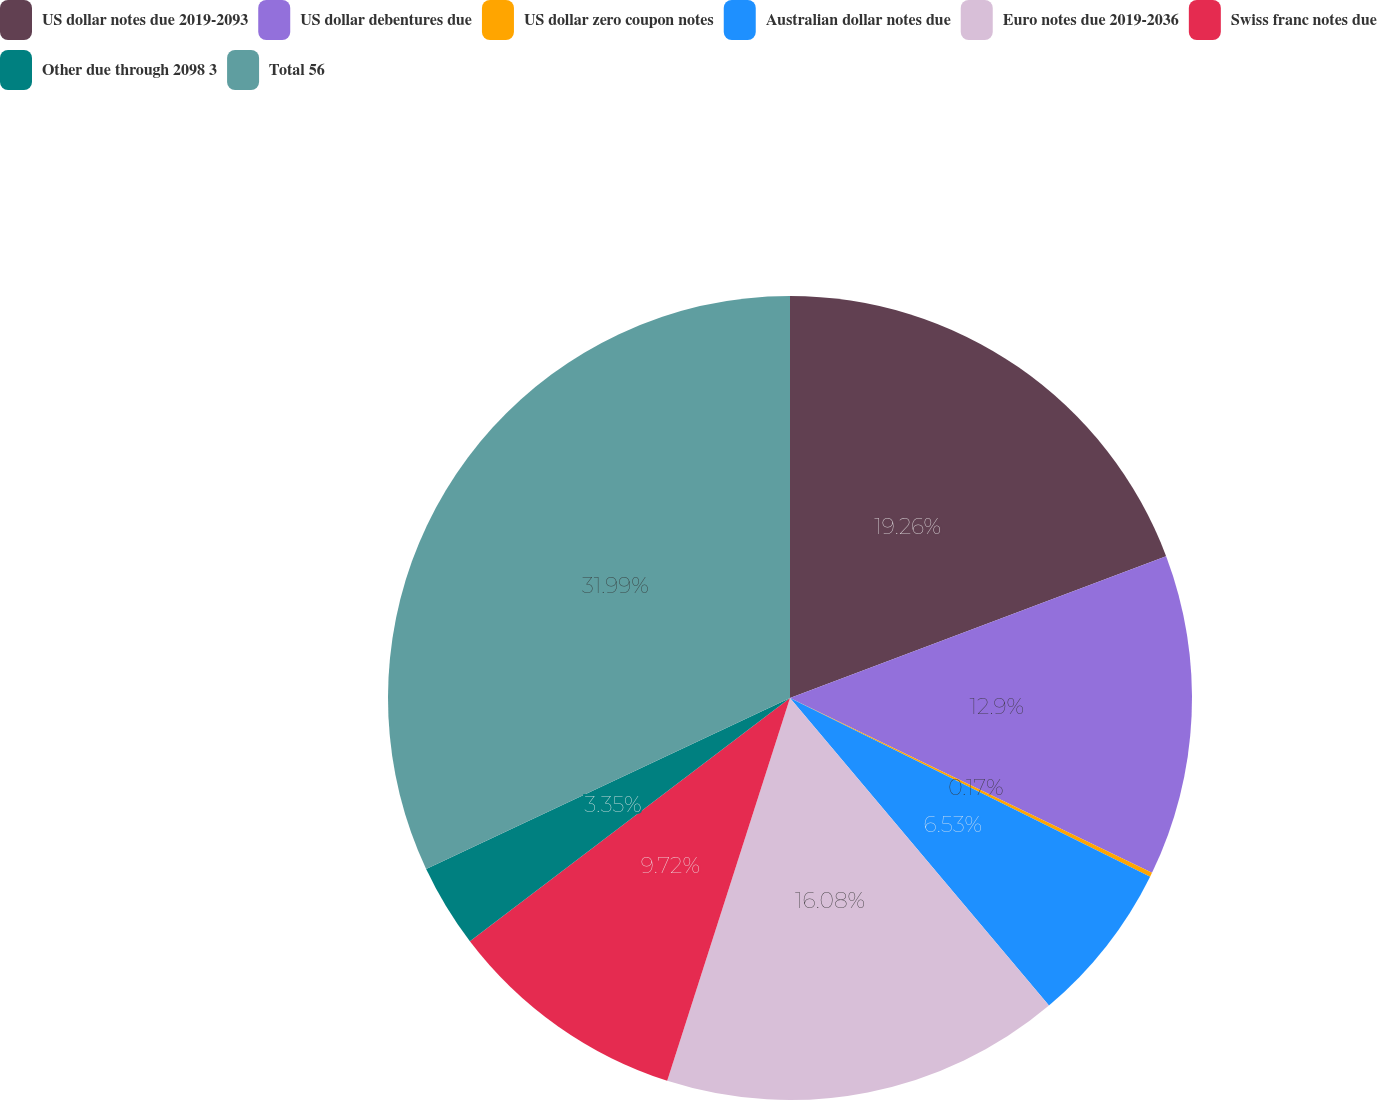Convert chart to OTSL. <chart><loc_0><loc_0><loc_500><loc_500><pie_chart><fcel>US dollar notes due 2019-2093<fcel>US dollar debentures due<fcel>US dollar zero coupon notes<fcel>Australian dollar notes due<fcel>Euro notes due 2019-2036<fcel>Swiss franc notes due<fcel>Other due through 2098 3<fcel>Total 56<nl><fcel>19.26%<fcel>12.9%<fcel>0.17%<fcel>6.53%<fcel>16.08%<fcel>9.72%<fcel>3.35%<fcel>31.99%<nl></chart> 